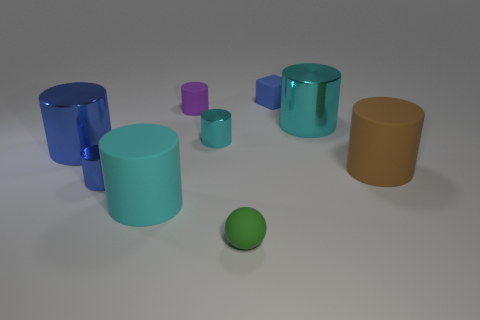What color is the small matte block? The small matte block appears to be a shade of cyan. It's a soft, muted color that distinguishes it from the surrounding objects which have more vibrant hues. 